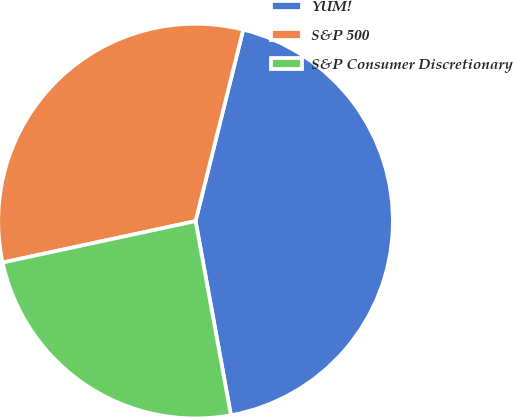Convert chart. <chart><loc_0><loc_0><loc_500><loc_500><pie_chart><fcel>YUM!<fcel>S&P 500<fcel>S&P Consumer Discretionary<nl><fcel>43.25%<fcel>32.25%<fcel>24.5%<nl></chart> 